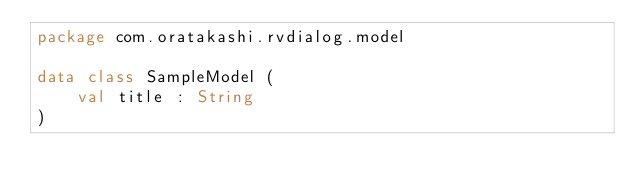Convert code to text. <code><loc_0><loc_0><loc_500><loc_500><_Kotlin_>package com.oratakashi.rvdialog.model

data class SampleModel (
    val title : String
)</code> 